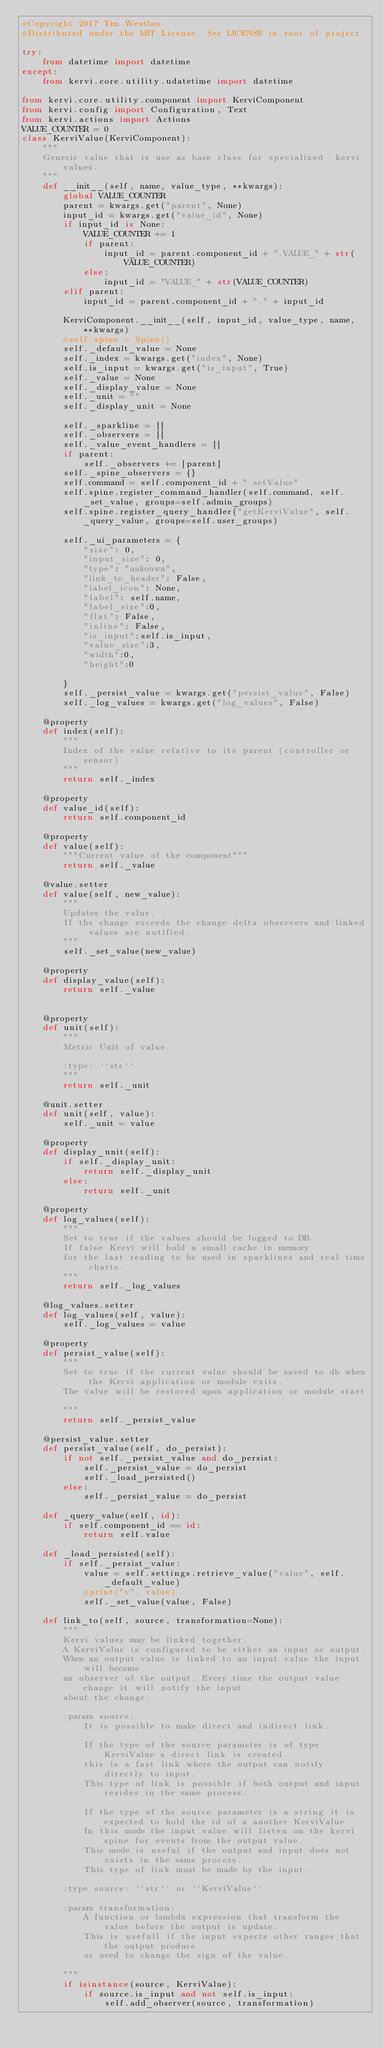Convert code to text. <code><loc_0><loc_0><loc_500><loc_500><_Python_>#Copyright 2017 Tim Wentlau.
#Distributed under the MIT License. See LICENSE in root of project.

try:
    from datetime import datetime
except:
    from kervi.core.utility.udatetime import datetime

from kervi.core.utility.component import KerviComponent
from kervi.config import Configuration, Text
from kervi.actions import Actions
VALUE_COUNTER = 0
class KerviValue(KerviComponent):
    """
    Generic value that is use as base class for specialized  kervi values.
    """
    def __init__(self, name, value_type, **kwargs):
        global VALUE_COUNTER
        parent = kwargs.get("parent", None)
        input_id = kwargs.get("value_id", None)
        if input_id is None:
            VALUE_COUNTER += 1
            if parent:
                input_id = parent.component_id + ".VALUE_" + str(VALUE_COUNTER)
            else:
                input_id = "VALUE_" + str(VALUE_COUNTER)
        elif parent:
            input_id = parent.component_id + "." + input_id

        KerviComponent.__init__(self, input_id, value_type, name, **kwargs)
        #self.spine = Spine()
        self._default_value = None
        self._index = kwargs.get("index", None)
        self.is_input = kwargs.get("is_input", True)
        self._value = None
        self._display_value = None
        self._unit = ""
        self._display_unit = None
        
        self._sparkline = []
        self._observers = []
        self._value_event_handlers = []
        if parent:
            self._observers += [parent]
        self._spine_observers = {}
        self.command = self.component_id + ".setValue"
        self.spine.register_command_handler(self.command, self._set_value, groups=self.admin_groups)
        self.spine.register_query_handler("getKerviValue", self._query_value, groups=self.user_groups)

        self._ui_parameters = {
            "size": 0,
            "input_size": 0,
            "type": "unkonwn",
            "link_to_header": False,
            "label_icon": None,
            "label": self.name,
            "label_size":0,
            "flat": False,
            "inline": False,
            "is_input":self.is_input,
            "value_size":3,
            "width":0,
            "height":0

        }
        self._persist_value = kwargs.get("persist_value", False)
        self._log_values = kwargs.get("log_values", False)

    @property
    def index(self):
        """
        Index of the value relative to its parent (controller or sensor)
        """
        return self._index

    @property
    def value_id(self):
        return self.component_id

    @property
    def value(self):
        """Current value of the component"""
        return self._value

    @value.setter
    def value(self, new_value):
        """
        Updates the value.
        If the change exceeds the change delta observers and linked values are notified.  
        """
        self._set_value(new_value)

    @property
    def display_value(self):
        return self._value

    
    @property
    def unit(self):
        """
        Metric Unit of value.

        :type: ``str``
        """
        return self._unit

    @unit.setter
    def unit(self, value):
        self._unit = value
    
    @property
    def display_unit(self):
        if self._display_unit:
            return self._display_unit
        else:
            return self._unit
    
    @property
    def log_values(self):
        """
        Set to true if the values should be logged to DB.
        If false Kervi will hold a small cache in memory
        for the last reading to be used in sparklines and real time charts.
        """
        return self._log_values

    @log_values.setter
    def log_values(self, value):
        self._log_values = value

    @property
    def persist_value(self):
        """
        Set to true if the current value should be saved to db when the Kervi application or module exits.
        The value will be restored upon application or module start. 
        """
        return self._persist_value

    @persist_value.setter
    def persist_value(self, do_persist):
        if not self._persist_value and do_persist:
            self._persist_value = do_persist
            self._load_persisted()
        else:
            self._persist_value = do_persist

    def _query_value(self, id):
        if self.component_id == id:
            return self.value

    def _load_persisted(self):
        if self._persist_value:
            value = self.settings.retrieve_value("value", self._default_value)
            #print("v", value)
            self._set_value(value, False)

    def link_to(self, source, transformation=None):
        """
        Kervi values may be linked together. 
        A KerviValue is configured to be either an input or output.
        When an output value is linked to an input value the input will become
        an observer of the output. Every time the output value change it will notify the input 
        about the change.

        :param source:
            It is possible to make direct and indirect link.

            If the type of the source parameter is of type KerviValue a direct link is created.
            this is a fast link where the output can notify directly to input.
            This type of link is possible if both output and input resides in the same process.

            If the type of the source parameter is a string it is expected to hold the id of a another KerviValue.
            In this mode the input value will listen on the kervi spine for events from the output value.
            This mode is useful if the output and input does not exists in the same process.
            This type of link must be made by the input.

        :type source: ``str`` or ``KerviValue``

        :param transformation:
            A function or lambda expression that transform the value before the output is update.
            This is usefull if the input expects other ranges that the output produce
            or need to change the sign of the value.

        """
        if isinstance(source, KerviValue):
            if source.is_input and not self.is_input:
                self.add_observer(source, transformation)</code> 